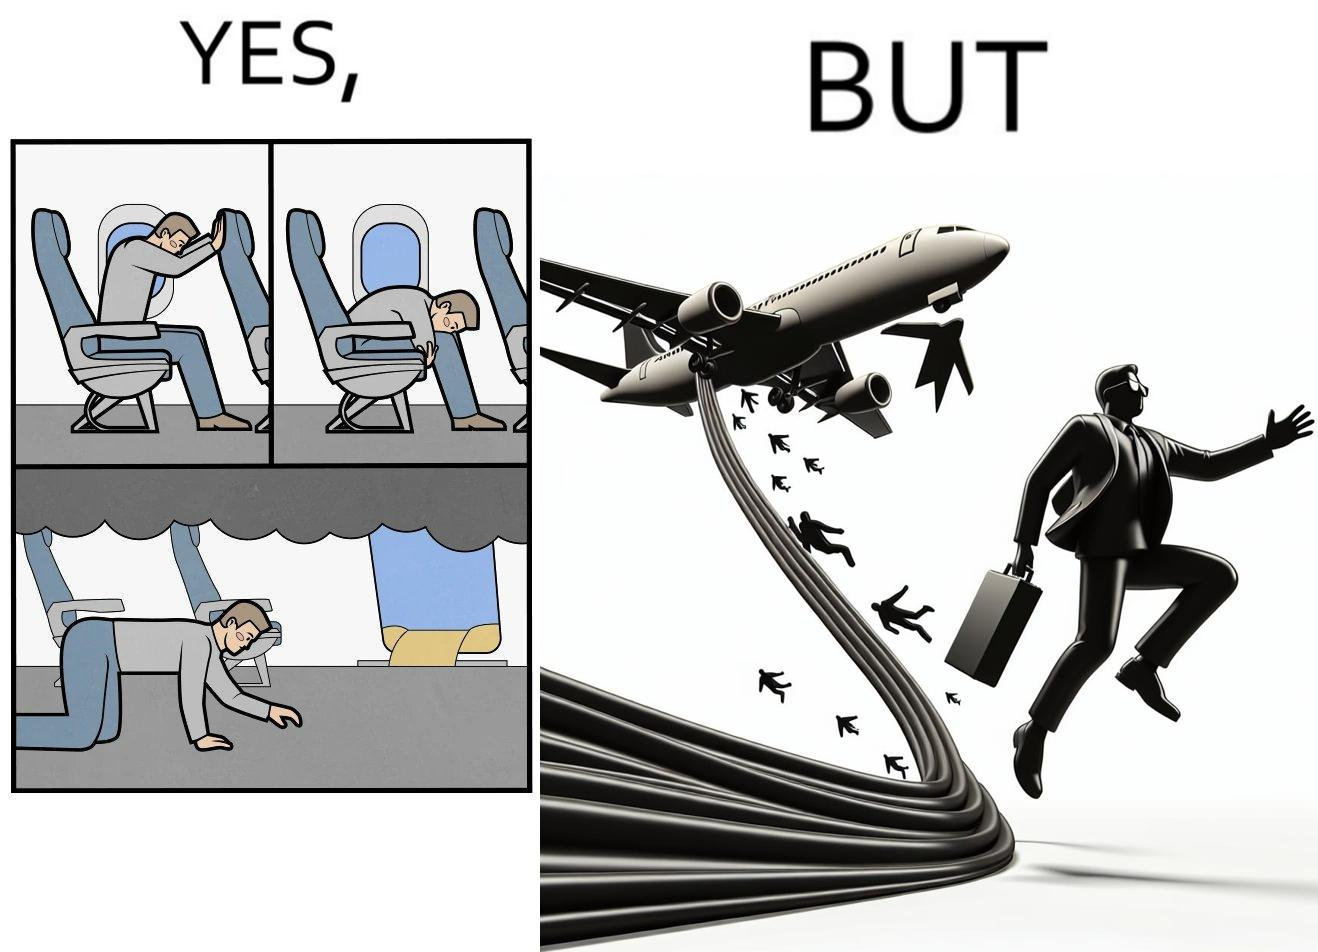Would you classify this image as satirical? Yes, this image is satirical. 